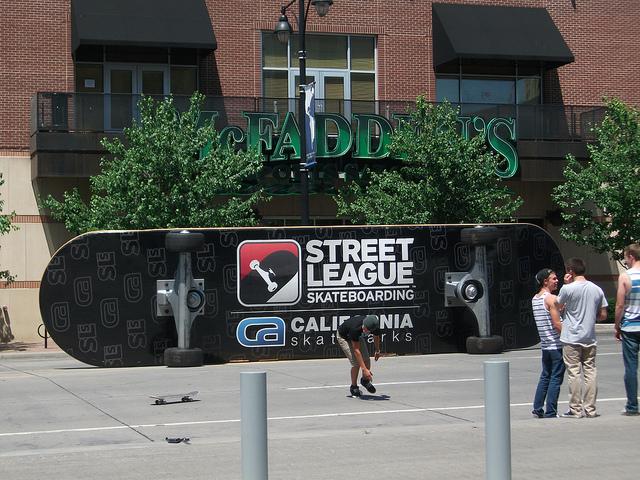Is it summertime in the picture?
Be succinct. Yes. What is the language of the sign?
Quick response, please. English. What does the sign above the walkway give directions to?
Short answer required. Street league skateboarding. What ad is the brand for?
Give a very brief answer. Street league. How is the skateboard so big?
Keep it brief. Advertisement. What does the skateboard read?
Write a very short answer. Street league skateboarding. Are there any women in the picture by the skateboard?
Be succinct. No. 